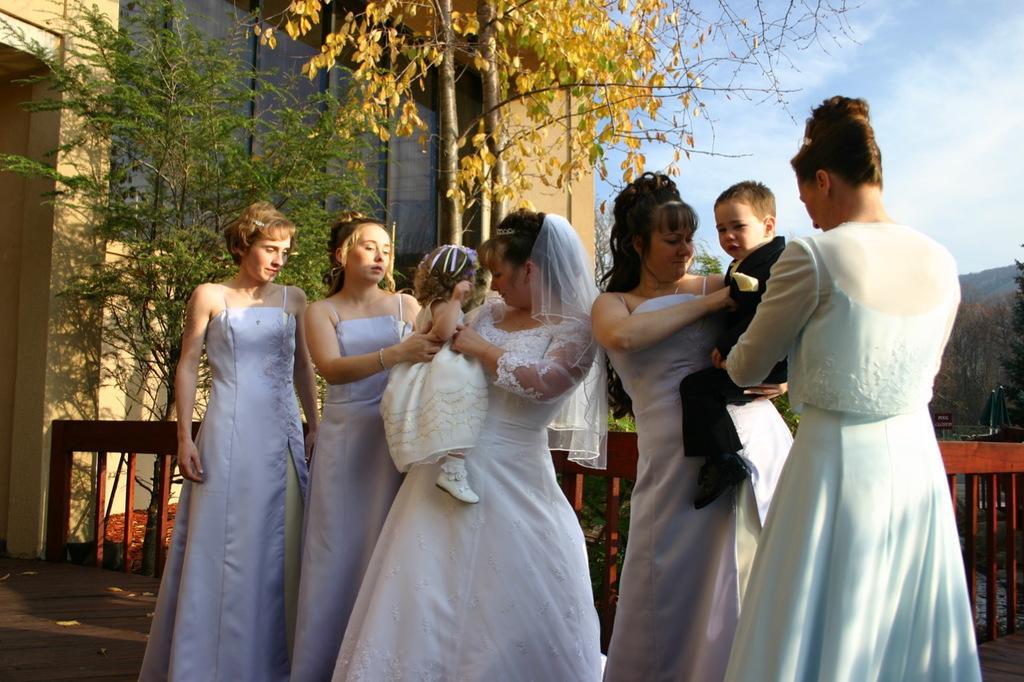Describe this image in one or two sentences. In this image, there are five persons standing. Among them two persons are carrying kids. Behind the people, I can see a wooden fence, trees and a building. At the bottom of the image, I can see a wooden pathway. On the right side of the image, there is a hill. In the background, there is the sky. 